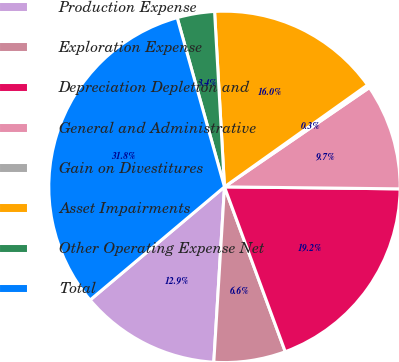Convert chart. <chart><loc_0><loc_0><loc_500><loc_500><pie_chart><fcel>Production Expense<fcel>Exploration Expense<fcel>Depreciation Depletion and<fcel>General and Administrative<fcel>Gain on Divestitures<fcel>Asset Impairments<fcel>Other Operating Expense Net<fcel>Total<nl><fcel>12.89%<fcel>6.59%<fcel>19.19%<fcel>9.74%<fcel>0.29%<fcel>16.04%<fcel>3.44%<fcel>31.79%<nl></chart> 